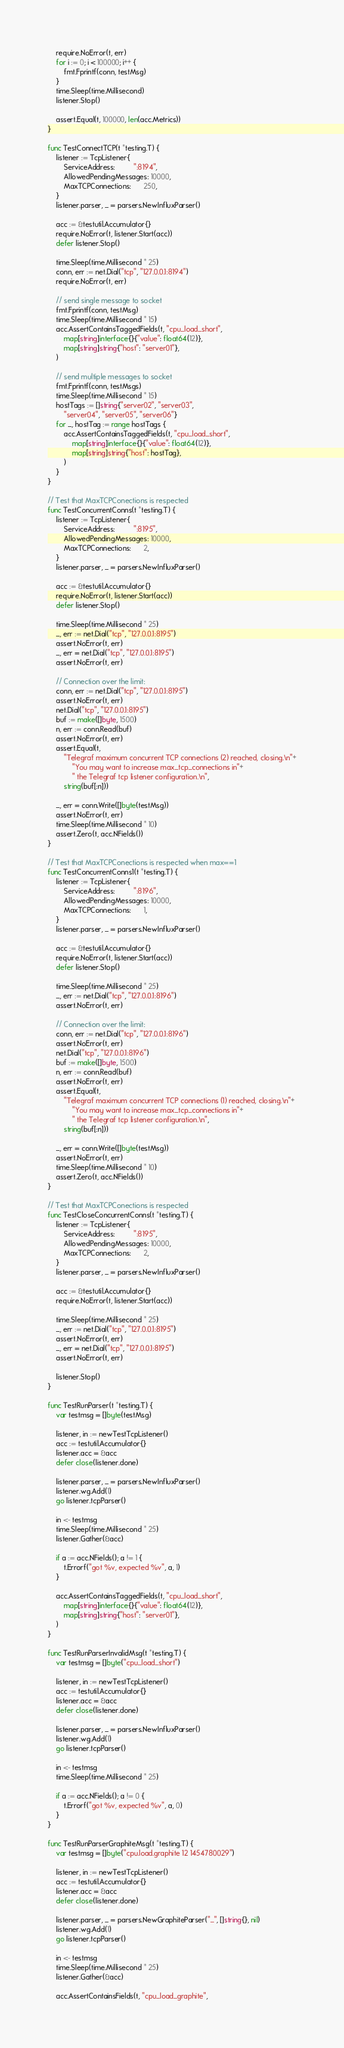<code> <loc_0><loc_0><loc_500><loc_500><_Go_>	require.NoError(t, err)
	for i := 0; i < 100000; i++ {
		fmt.Fprintf(conn, testMsg)
	}
	time.Sleep(time.Millisecond)
	listener.Stop()

	assert.Equal(t, 100000, len(acc.Metrics))
}

func TestConnectTCP(t *testing.T) {
	listener := TcpListener{
		ServiceAddress:         ":8194",
		AllowedPendingMessages: 10000,
		MaxTCPConnections:      250,
	}
	listener.parser, _ = parsers.NewInfluxParser()

	acc := &testutil.Accumulator{}
	require.NoError(t, listener.Start(acc))
	defer listener.Stop()

	time.Sleep(time.Millisecond * 25)
	conn, err := net.Dial("tcp", "127.0.0.1:8194")
	require.NoError(t, err)

	// send single message to socket
	fmt.Fprintf(conn, testMsg)
	time.Sleep(time.Millisecond * 15)
	acc.AssertContainsTaggedFields(t, "cpu_load_short",
		map[string]interface{}{"value": float64(12)},
		map[string]string{"host": "server01"},
	)

	// send multiple messages to socket
	fmt.Fprintf(conn, testMsgs)
	time.Sleep(time.Millisecond * 15)
	hostTags := []string{"server02", "server03",
		"server04", "server05", "server06"}
	for _, hostTag := range hostTags {
		acc.AssertContainsTaggedFields(t, "cpu_load_short",
			map[string]interface{}{"value": float64(12)},
			map[string]string{"host": hostTag},
		)
	}
}

// Test that MaxTCPConections is respected
func TestConcurrentConns(t *testing.T) {
	listener := TcpListener{
		ServiceAddress:         ":8195",
		AllowedPendingMessages: 10000,
		MaxTCPConnections:      2,
	}
	listener.parser, _ = parsers.NewInfluxParser()

	acc := &testutil.Accumulator{}
	require.NoError(t, listener.Start(acc))
	defer listener.Stop()

	time.Sleep(time.Millisecond * 25)
	_, err := net.Dial("tcp", "127.0.0.1:8195")
	assert.NoError(t, err)
	_, err = net.Dial("tcp", "127.0.0.1:8195")
	assert.NoError(t, err)

	// Connection over the limit:
	conn, err := net.Dial("tcp", "127.0.0.1:8195")
	assert.NoError(t, err)
	net.Dial("tcp", "127.0.0.1:8195")
	buf := make([]byte, 1500)
	n, err := conn.Read(buf)
	assert.NoError(t, err)
	assert.Equal(t,
		"Telegraf maximum concurrent TCP connections (2) reached, closing.\n"+
			"You may want to increase max_tcp_connections in"+
			" the Telegraf tcp listener configuration.\n",
		string(buf[:n]))

	_, err = conn.Write([]byte(testMsg))
	assert.NoError(t, err)
	time.Sleep(time.Millisecond * 10)
	assert.Zero(t, acc.NFields())
}

// Test that MaxTCPConections is respected when max==1
func TestConcurrentConns1(t *testing.T) {
	listener := TcpListener{
		ServiceAddress:         ":8196",
		AllowedPendingMessages: 10000,
		MaxTCPConnections:      1,
	}
	listener.parser, _ = parsers.NewInfluxParser()

	acc := &testutil.Accumulator{}
	require.NoError(t, listener.Start(acc))
	defer listener.Stop()

	time.Sleep(time.Millisecond * 25)
	_, err := net.Dial("tcp", "127.0.0.1:8196")
	assert.NoError(t, err)

	// Connection over the limit:
	conn, err := net.Dial("tcp", "127.0.0.1:8196")
	assert.NoError(t, err)
	net.Dial("tcp", "127.0.0.1:8196")
	buf := make([]byte, 1500)
	n, err := conn.Read(buf)
	assert.NoError(t, err)
	assert.Equal(t,
		"Telegraf maximum concurrent TCP connections (1) reached, closing.\n"+
			"You may want to increase max_tcp_connections in"+
			" the Telegraf tcp listener configuration.\n",
		string(buf[:n]))

	_, err = conn.Write([]byte(testMsg))
	assert.NoError(t, err)
	time.Sleep(time.Millisecond * 10)
	assert.Zero(t, acc.NFields())
}

// Test that MaxTCPConections is respected
func TestCloseConcurrentConns(t *testing.T) {
	listener := TcpListener{
		ServiceAddress:         ":8195",
		AllowedPendingMessages: 10000,
		MaxTCPConnections:      2,
	}
	listener.parser, _ = parsers.NewInfluxParser()

	acc := &testutil.Accumulator{}
	require.NoError(t, listener.Start(acc))

	time.Sleep(time.Millisecond * 25)
	_, err := net.Dial("tcp", "127.0.0.1:8195")
	assert.NoError(t, err)
	_, err = net.Dial("tcp", "127.0.0.1:8195")
	assert.NoError(t, err)

	listener.Stop()
}

func TestRunParser(t *testing.T) {
	var testmsg = []byte(testMsg)

	listener, in := newTestTcpListener()
	acc := testutil.Accumulator{}
	listener.acc = &acc
	defer close(listener.done)

	listener.parser, _ = parsers.NewInfluxParser()
	listener.wg.Add(1)
	go listener.tcpParser()

	in <- testmsg
	time.Sleep(time.Millisecond * 25)
	listener.Gather(&acc)

	if a := acc.NFields(); a != 1 {
		t.Errorf("got %v, expected %v", a, 1)
	}

	acc.AssertContainsTaggedFields(t, "cpu_load_short",
		map[string]interface{}{"value": float64(12)},
		map[string]string{"host": "server01"},
	)
}

func TestRunParserInvalidMsg(t *testing.T) {
	var testmsg = []byte("cpu_load_short")

	listener, in := newTestTcpListener()
	acc := testutil.Accumulator{}
	listener.acc = &acc
	defer close(listener.done)

	listener.parser, _ = parsers.NewInfluxParser()
	listener.wg.Add(1)
	go listener.tcpParser()

	in <- testmsg
	time.Sleep(time.Millisecond * 25)

	if a := acc.NFields(); a != 0 {
		t.Errorf("got %v, expected %v", a, 0)
	}
}

func TestRunParserGraphiteMsg(t *testing.T) {
	var testmsg = []byte("cpu.load.graphite 12 1454780029")

	listener, in := newTestTcpListener()
	acc := testutil.Accumulator{}
	listener.acc = &acc
	defer close(listener.done)

	listener.parser, _ = parsers.NewGraphiteParser("_", []string{}, nil)
	listener.wg.Add(1)
	go listener.tcpParser()

	in <- testmsg
	time.Sleep(time.Millisecond * 25)
	listener.Gather(&acc)

	acc.AssertContainsFields(t, "cpu_load_graphite",</code> 